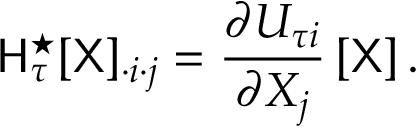<formula> <loc_0><loc_0><loc_500><loc_500>H _ { \tau } ^ { ^ { * } } [ X ] _ { \cdot i \cdot j } = \frac { \partial U _ { \tau i } } { \partial X _ { j } } \left [ X \right ] .</formula> 